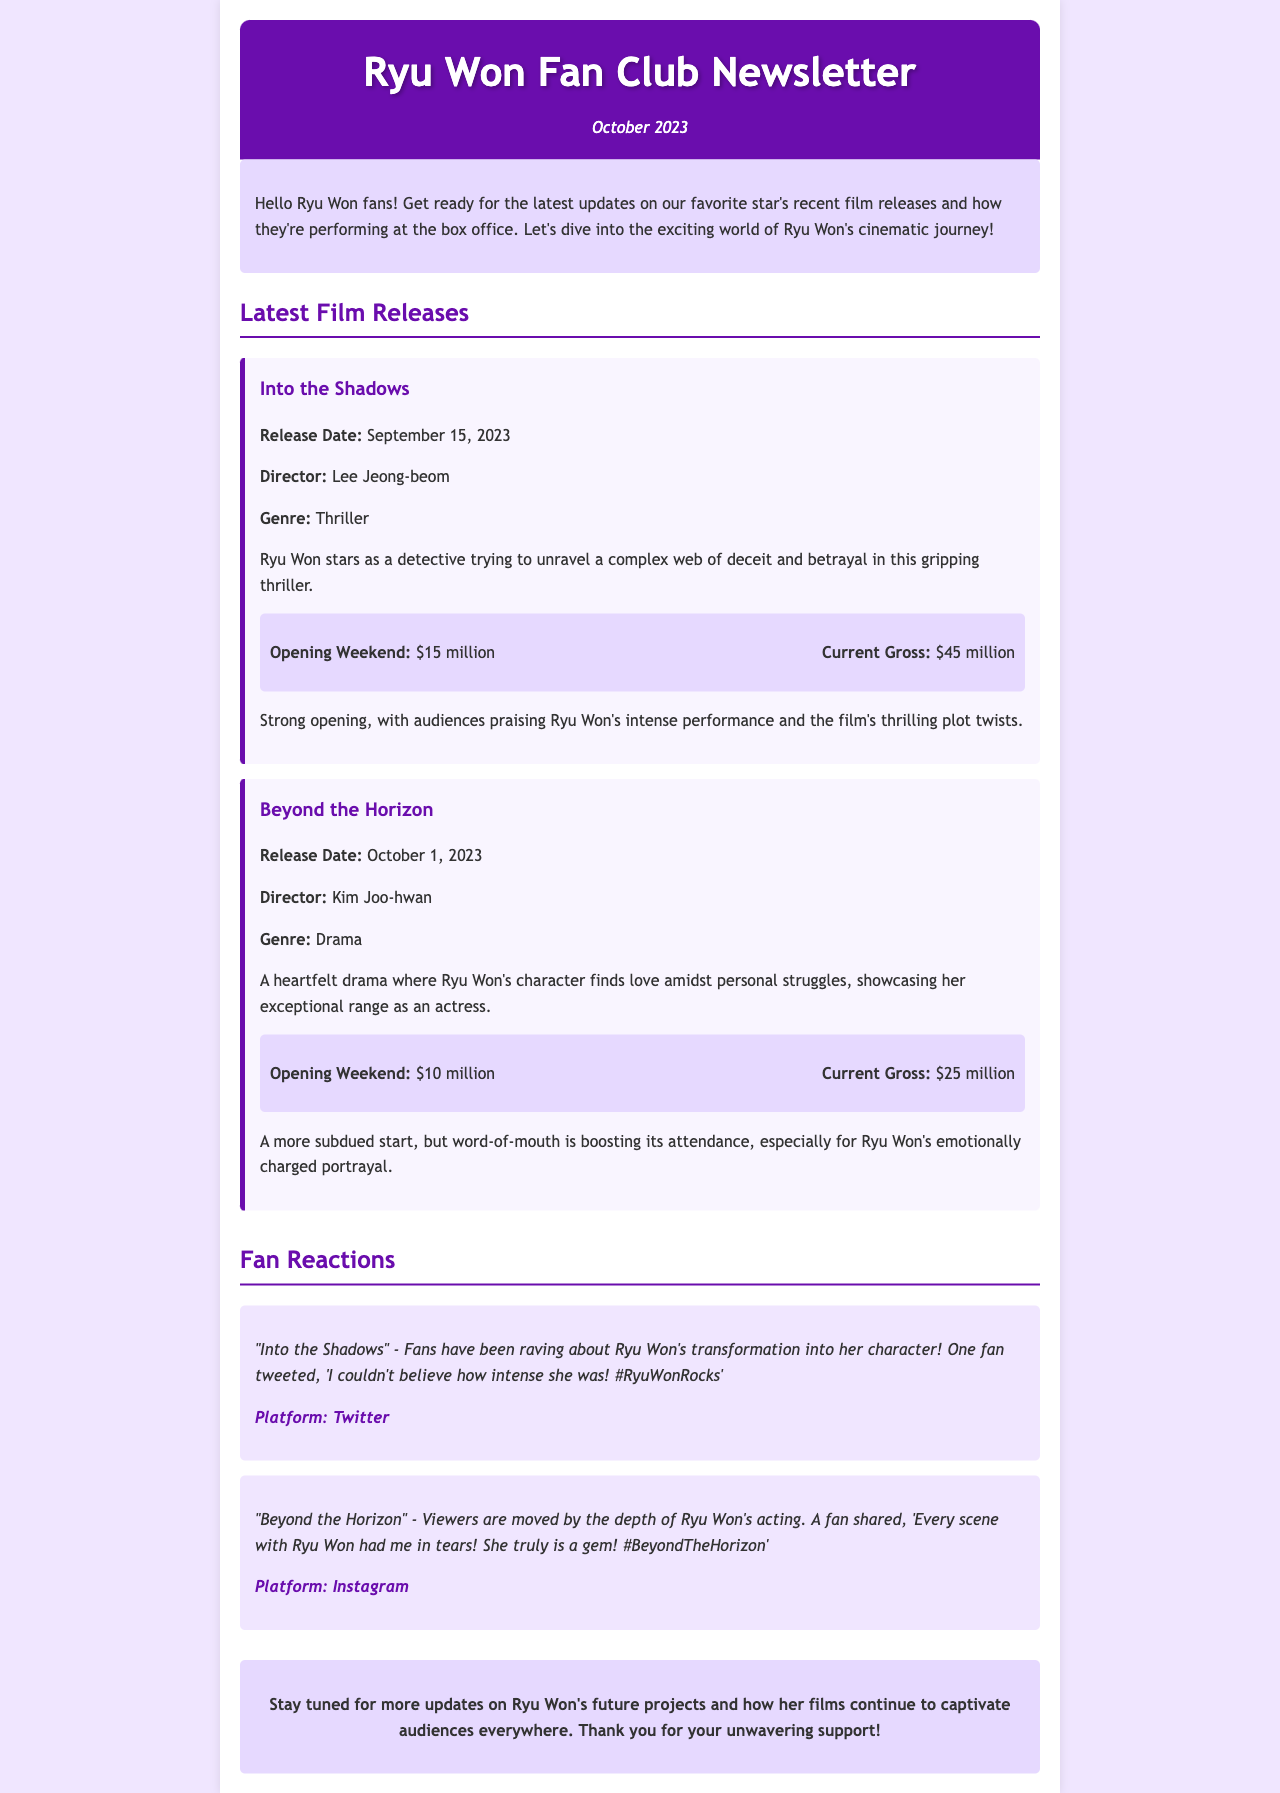What is the release date of "Into the Shadows"? The release date is specified in the document under the film section for "Into the Shadows."
Answer: September 15, 2023 Who directed "Beyond the Horizon"? The director's name is mentioned in the film section for "Beyond the Horizon."
Answer: Kim Joo-hwan What was the opening weekend revenue for "Into the Shadows"? The opening weekend revenue is listed in the box office section for "Into the Shadows."
Answer: $15 million Which film features a detective character played by Ryu Won? The film is mentioned in the latest film releases section which describes Ryu Won's role.
Answer: Into the Shadows What are fans acknowledging about Ryu Won's performance in "Beyond the Horizon"? The fan reaction section includes direct quotes reflecting on her performance in "Beyond the Horizon."
Answer: Depth of her acting How much is the current gross for "Beyond the Horizon"? Current gross revenue is detailed in the box office section for "Beyond the Horizon."
Answer: $25 million 